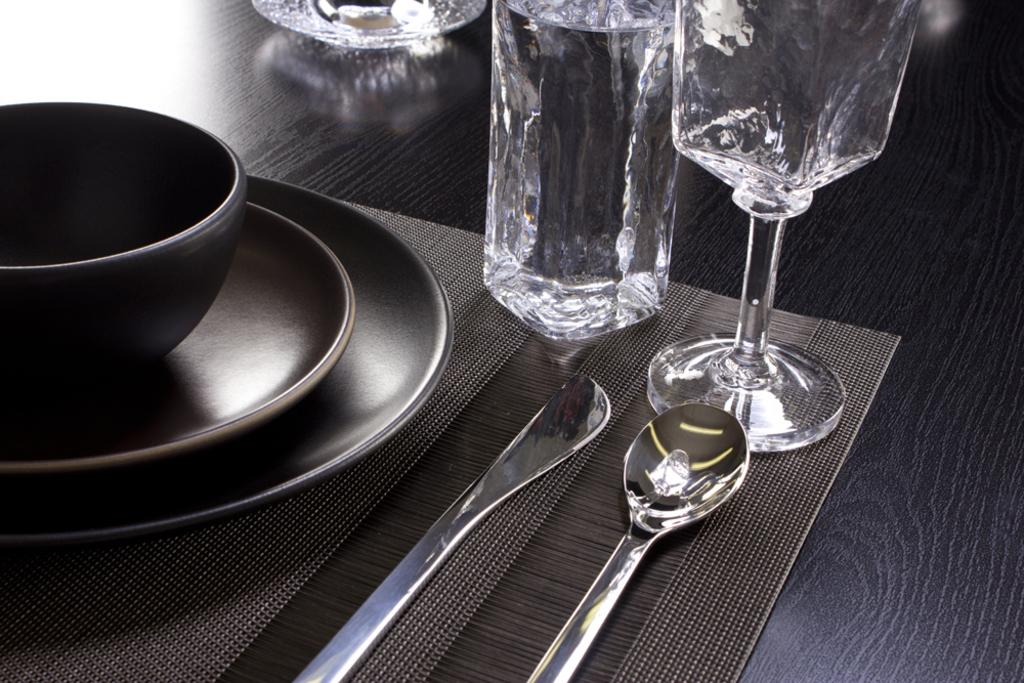What type of tableware can be seen on the table in the image? There are glasses, spoons, bowls, and plates on the table in the image. What other objects are present on the table? There are other objects on the table, but their specific nature is not mentioned in the provided facts. Can you describe the arrangement of the tableware on the table? The arrangement of the tableware is not mentioned in the provided facts, so it cannot be described. What type of mountain is visible in the background of the image? There is no mountain visible in the background of the image. What type of poison is being served in the glasses on the table? There is no mention of poison in the provided facts, and the contents of the glasses are not specified. 